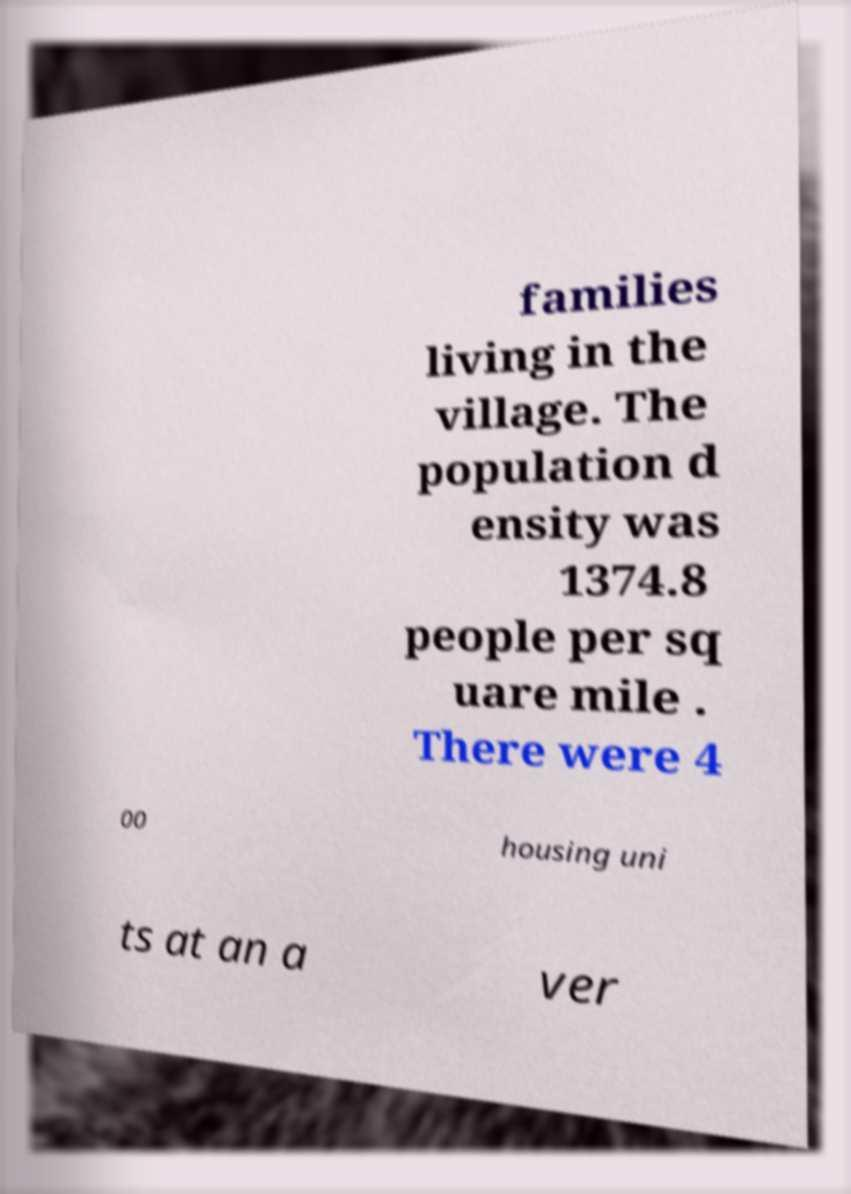I need the written content from this picture converted into text. Can you do that? families living in the village. The population d ensity was 1374.8 people per sq uare mile . There were 4 00 housing uni ts at an a ver 